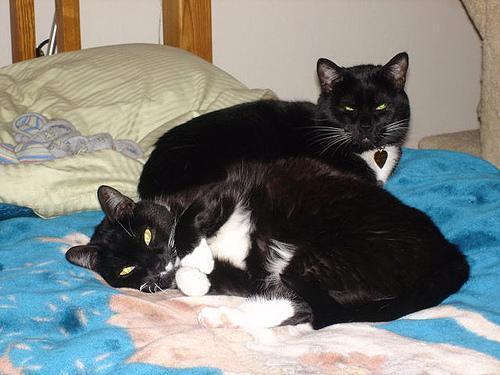How many cats are there?
Give a very brief answer. 2. How many cats are in the photo?
Give a very brief answer. 2. 